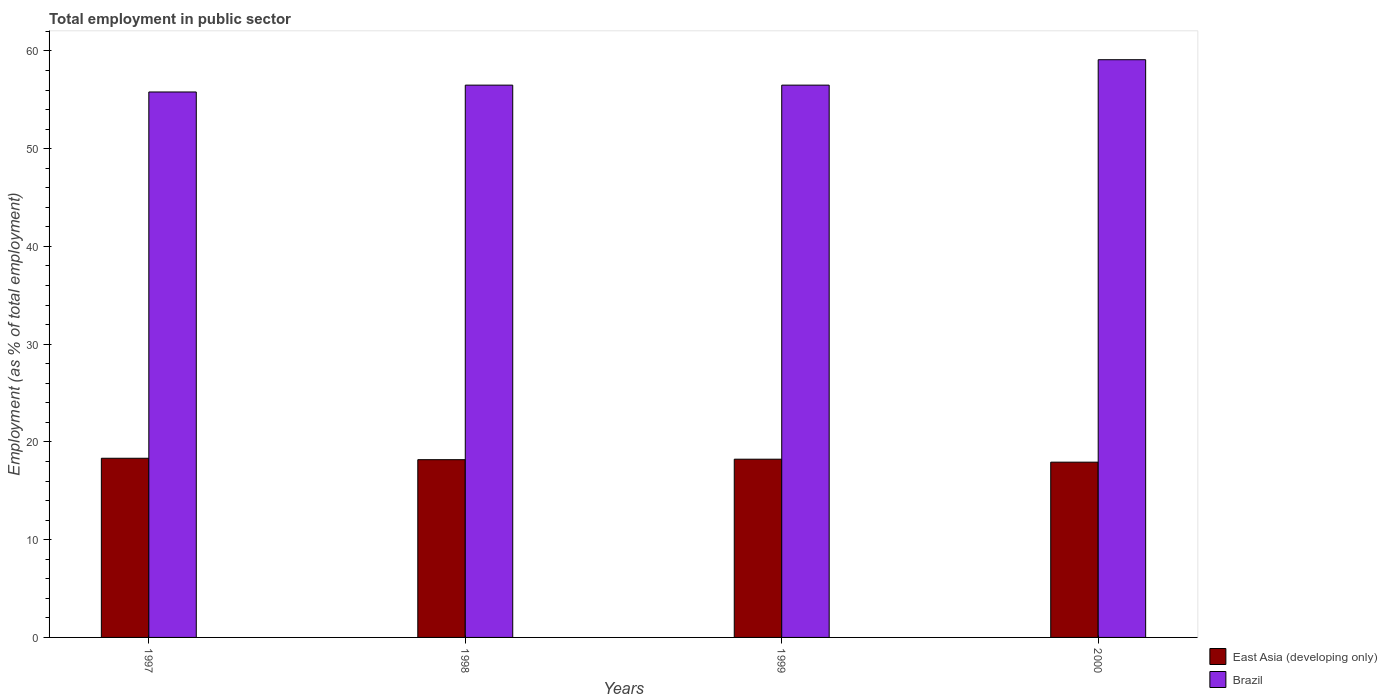How many groups of bars are there?
Offer a terse response. 4. Are the number of bars on each tick of the X-axis equal?
Your answer should be compact. Yes. How many bars are there on the 3rd tick from the right?
Your answer should be very brief. 2. In how many cases, is the number of bars for a given year not equal to the number of legend labels?
Offer a terse response. 0. What is the employment in public sector in East Asia (developing only) in 1997?
Offer a terse response. 18.33. Across all years, what is the maximum employment in public sector in Brazil?
Make the answer very short. 59.1. Across all years, what is the minimum employment in public sector in East Asia (developing only)?
Offer a terse response. 17.93. What is the total employment in public sector in East Asia (developing only) in the graph?
Give a very brief answer. 72.67. What is the difference between the employment in public sector in Brazil in 1999 and that in 2000?
Make the answer very short. -2.6. What is the difference between the employment in public sector in Brazil in 2000 and the employment in public sector in East Asia (developing only) in 1998?
Your answer should be compact. 40.92. What is the average employment in public sector in East Asia (developing only) per year?
Make the answer very short. 18.17. In the year 1998, what is the difference between the employment in public sector in East Asia (developing only) and employment in public sector in Brazil?
Ensure brevity in your answer.  -38.32. What is the ratio of the employment in public sector in Brazil in 1997 to that in 1998?
Keep it short and to the point. 0.99. What is the difference between the highest and the second highest employment in public sector in East Asia (developing only)?
Give a very brief answer. 0.1. What is the difference between the highest and the lowest employment in public sector in East Asia (developing only)?
Give a very brief answer. 0.4. In how many years, is the employment in public sector in East Asia (developing only) greater than the average employment in public sector in East Asia (developing only) taken over all years?
Your answer should be compact. 3. Is the sum of the employment in public sector in Brazil in 1998 and 1999 greater than the maximum employment in public sector in East Asia (developing only) across all years?
Ensure brevity in your answer.  Yes. What does the 2nd bar from the right in 2000 represents?
Your answer should be very brief. East Asia (developing only). How many bars are there?
Your answer should be very brief. 8. Are all the bars in the graph horizontal?
Your answer should be very brief. No. How many years are there in the graph?
Your response must be concise. 4. What is the difference between two consecutive major ticks on the Y-axis?
Ensure brevity in your answer.  10. Are the values on the major ticks of Y-axis written in scientific E-notation?
Provide a short and direct response. No. Does the graph contain any zero values?
Make the answer very short. No. Does the graph contain grids?
Ensure brevity in your answer.  No. How many legend labels are there?
Offer a very short reply. 2. How are the legend labels stacked?
Your response must be concise. Vertical. What is the title of the graph?
Offer a terse response. Total employment in public sector. What is the label or title of the X-axis?
Offer a terse response. Years. What is the label or title of the Y-axis?
Offer a very short reply. Employment (as % of total employment). What is the Employment (as % of total employment) in East Asia (developing only) in 1997?
Offer a very short reply. 18.33. What is the Employment (as % of total employment) in Brazil in 1997?
Your answer should be very brief. 55.8. What is the Employment (as % of total employment) in East Asia (developing only) in 1998?
Offer a very short reply. 18.18. What is the Employment (as % of total employment) of Brazil in 1998?
Your answer should be compact. 56.5. What is the Employment (as % of total employment) in East Asia (developing only) in 1999?
Keep it short and to the point. 18.23. What is the Employment (as % of total employment) in Brazil in 1999?
Make the answer very short. 56.5. What is the Employment (as % of total employment) in East Asia (developing only) in 2000?
Your response must be concise. 17.93. What is the Employment (as % of total employment) in Brazil in 2000?
Your answer should be very brief. 59.1. Across all years, what is the maximum Employment (as % of total employment) of East Asia (developing only)?
Keep it short and to the point. 18.33. Across all years, what is the maximum Employment (as % of total employment) of Brazil?
Your answer should be very brief. 59.1. Across all years, what is the minimum Employment (as % of total employment) in East Asia (developing only)?
Give a very brief answer. 17.93. Across all years, what is the minimum Employment (as % of total employment) in Brazil?
Offer a very short reply. 55.8. What is the total Employment (as % of total employment) of East Asia (developing only) in the graph?
Provide a succinct answer. 72.67. What is the total Employment (as % of total employment) in Brazil in the graph?
Your answer should be very brief. 227.9. What is the difference between the Employment (as % of total employment) in East Asia (developing only) in 1997 and that in 1998?
Ensure brevity in your answer.  0.15. What is the difference between the Employment (as % of total employment) of East Asia (developing only) in 1997 and that in 1999?
Provide a short and direct response. 0.1. What is the difference between the Employment (as % of total employment) in Brazil in 1997 and that in 1999?
Provide a succinct answer. -0.7. What is the difference between the Employment (as % of total employment) of East Asia (developing only) in 1997 and that in 2000?
Offer a very short reply. 0.4. What is the difference between the Employment (as % of total employment) of Brazil in 1997 and that in 2000?
Your answer should be compact. -3.3. What is the difference between the Employment (as % of total employment) in East Asia (developing only) in 1998 and that in 1999?
Give a very brief answer. -0.05. What is the difference between the Employment (as % of total employment) of Brazil in 1998 and that in 1999?
Offer a terse response. 0. What is the difference between the Employment (as % of total employment) in East Asia (developing only) in 1998 and that in 2000?
Ensure brevity in your answer.  0.25. What is the difference between the Employment (as % of total employment) of East Asia (developing only) in 1999 and that in 2000?
Provide a succinct answer. 0.3. What is the difference between the Employment (as % of total employment) of Brazil in 1999 and that in 2000?
Make the answer very short. -2.6. What is the difference between the Employment (as % of total employment) in East Asia (developing only) in 1997 and the Employment (as % of total employment) in Brazil in 1998?
Provide a succinct answer. -38.17. What is the difference between the Employment (as % of total employment) in East Asia (developing only) in 1997 and the Employment (as % of total employment) in Brazil in 1999?
Keep it short and to the point. -38.17. What is the difference between the Employment (as % of total employment) in East Asia (developing only) in 1997 and the Employment (as % of total employment) in Brazil in 2000?
Offer a very short reply. -40.77. What is the difference between the Employment (as % of total employment) of East Asia (developing only) in 1998 and the Employment (as % of total employment) of Brazil in 1999?
Your response must be concise. -38.32. What is the difference between the Employment (as % of total employment) of East Asia (developing only) in 1998 and the Employment (as % of total employment) of Brazil in 2000?
Keep it short and to the point. -40.92. What is the difference between the Employment (as % of total employment) in East Asia (developing only) in 1999 and the Employment (as % of total employment) in Brazil in 2000?
Provide a short and direct response. -40.87. What is the average Employment (as % of total employment) of East Asia (developing only) per year?
Provide a short and direct response. 18.17. What is the average Employment (as % of total employment) of Brazil per year?
Your response must be concise. 56.98. In the year 1997, what is the difference between the Employment (as % of total employment) of East Asia (developing only) and Employment (as % of total employment) of Brazil?
Offer a terse response. -37.47. In the year 1998, what is the difference between the Employment (as % of total employment) in East Asia (developing only) and Employment (as % of total employment) in Brazil?
Provide a succinct answer. -38.32. In the year 1999, what is the difference between the Employment (as % of total employment) in East Asia (developing only) and Employment (as % of total employment) in Brazil?
Give a very brief answer. -38.27. In the year 2000, what is the difference between the Employment (as % of total employment) in East Asia (developing only) and Employment (as % of total employment) in Brazil?
Offer a very short reply. -41.17. What is the ratio of the Employment (as % of total employment) of East Asia (developing only) in 1997 to that in 1998?
Your response must be concise. 1.01. What is the ratio of the Employment (as % of total employment) in Brazil in 1997 to that in 1998?
Provide a succinct answer. 0.99. What is the ratio of the Employment (as % of total employment) in Brazil in 1997 to that in 1999?
Ensure brevity in your answer.  0.99. What is the ratio of the Employment (as % of total employment) in East Asia (developing only) in 1997 to that in 2000?
Offer a very short reply. 1.02. What is the ratio of the Employment (as % of total employment) in Brazil in 1997 to that in 2000?
Keep it short and to the point. 0.94. What is the ratio of the Employment (as % of total employment) in East Asia (developing only) in 1998 to that in 2000?
Ensure brevity in your answer.  1.01. What is the ratio of the Employment (as % of total employment) in Brazil in 1998 to that in 2000?
Provide a short and direct response. 0.96. What is the ratio of the Employment (as % of total employment) of Brazil in 1999 to that in 2000?
Make the answer very short. 0.96. What is the difference between the highest and the second highest Employment (as % of total employment) in East Asia (developing only)?
Provide a short and direct response. 0.1. What is the difference between the highest and the second highest Employment (as % of total employment) in Brazil?
Keep it short and to the point. 2.6. What is the difference between the highest and the lowest Employment (as % of total employment) in East Asia (developing only)?
Offer a terse response. 0.4. 